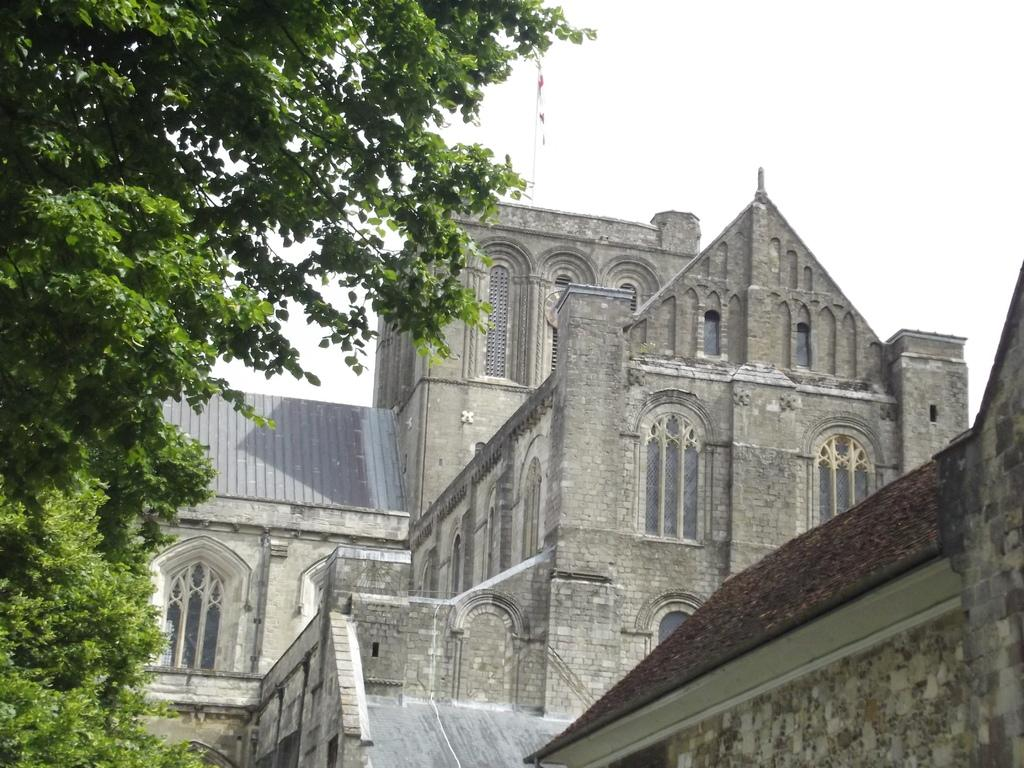What structure is located on the right side of the image? There is a building on the right side of the image. What features can be observed on the building? The building has many windows and doors. What is on the left side of the image? There is a tree on the left side of the image. What is visible above the tree? The sky is visible above the tree. What type of wood is the servant using to make cream in the image? There is no wood, servant, or cream present in the image. 